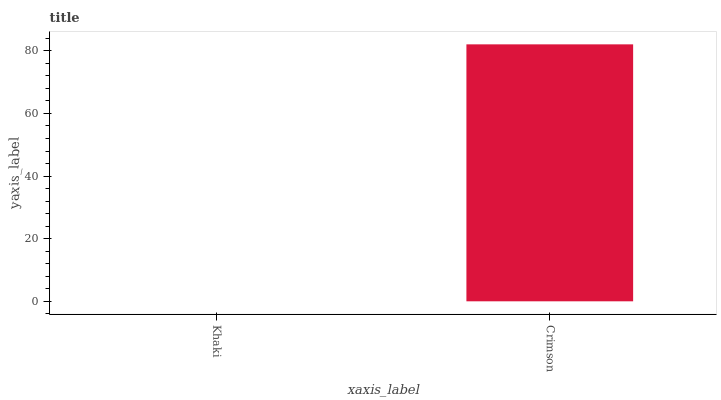Is Crimson the minimum?
Answer yes or no. No. Is Crimson greater than Khaki?
Answer yes or no. Yes. Is Khaki less than Crimson?
Answer yes or no. Yes. Is Khaki greater than Crimson?
Answer yes or no. No. Is Crimson less than Khaki?
Answer yes or no. No. Is Crimson the high median?
Answer yes or no. Yes. Is Khaki the low median?
Answer yes or no. Yes. Is Khaki the high median?
Answer yes or no. No. Is Crimson the low median?
Answer yes or no. No. 